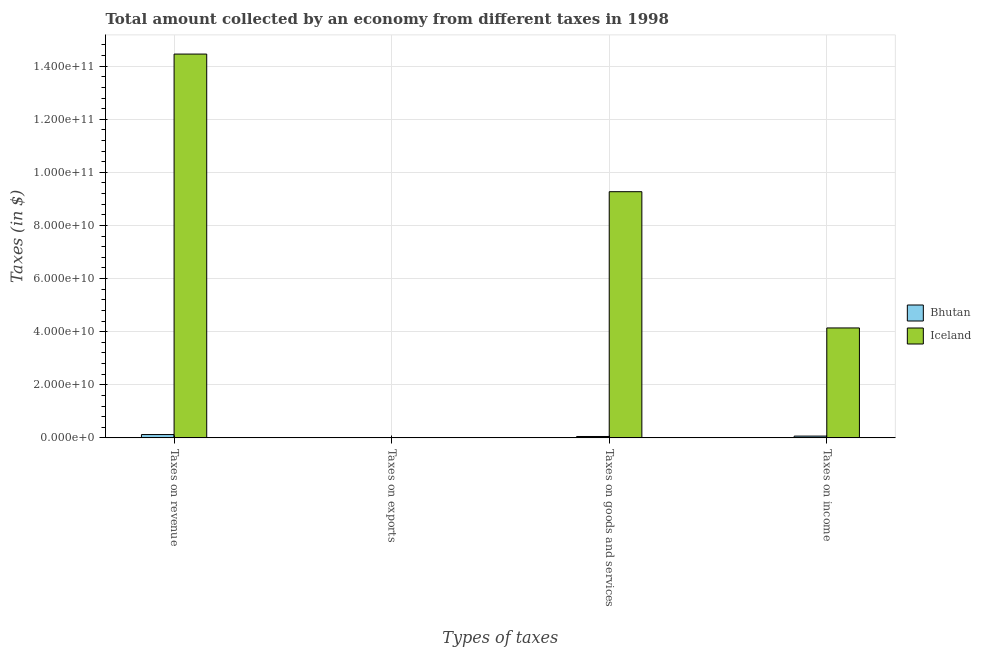How many groups of bars are there?
Your answer should be very brief. 4. Are the number of bars per tick equal to the number of legend labels?
Give a very brief answer. Yes. How many bars are there on the 1st tick from the right?
Your answer should be compact. 2. What is the label of the 3rd group of bars from the left?
Your answer should be very brief. Taxes on goods and services. What is the amount collected as tax on goods in Iceland?
Ensure brevity in your answer.  9.27e+1. Across all countries, what is the maximum amount collected as tax on income?
Provide a short and direct response. 4.14e+1. Across all countries, what is the minimum amount collected as tax on income?
Provide a succinct answer. 6.68e+08. In which country was the amount collected as tax on revenue minimum?
Provide a short and direct response. Bhutan. What is the total amount collected as tax on goods in the graph?
Give a very brief answer. 9.32e+1. What is the difference between the amount collected as tax on goods in Bhutan and that in Iceland?
Your response must be concise. -9.22e+1. What is the difference between the amount collected as tax on revenue in Iceland and the amount collected as tax on income in Bhutan?
Your response must be concise. 1.44e+11. What is the average amount collected as tax on revenue per country?
Your answer should be very brief. 7.29e+1. What is the difference between the amount collected as tax on exports and amount collected as tax on goods in Bhutan?
Give a very brief answer. -5.01e+08. What is the ratio of the amount collected as tax on revenue in Iceland to that in Bhutan?
Make the answer very short. 115.97. Is the amount collected as tax on revenue in Bhutan less than that in Iceland?
Offer a terse response. Yes. Is the difference between the amount collected as tax on exports in Bhutan and Iceland greater than the difference between the amount collected as tax on income in Bhutan and Iceland?
Offer a very short reply. Yes. What is the difference between the highest and the second highest amount collected as tax on exports?
Provide a short and direct response. 4.13e+07. What is the difference between the highest and the lowest amount collected as tax on goods?
Your answer should be compact. 9.22e+1. Is the sum of the amount collected as tax on exports in Iceland and Bhutan greater than the maximum amount collected as tax on goods across all countries?
Ensure brevity in your answer.  No. What does the 2nd bar from the left in Taxes on income represents?
Offer a terse response. Iceland. What does the 1st bar from the right in Taxes on goods and services represents?
Provide a succinct answer. Iceland. How many bars are there?
Your answer should be very brief. 8. What is the difference between two consecutive major ticks on the Y-axis?
Ensure brevity in your answer.  2.00e+1. Does the graph contain any zero values?
Provide a short and direct response. No. Where does the legend appear in the graph?
Offer a terse response. Center right. How are the legend labels stacked?
Your answer should be compact. Vertical. What is the title of the graph?
Keep it short and to the point. Total amount collected by an economy from different taxes in 1998. What is the label or title of the X-axis?
Make the answer very short. Types of taxes. What is the label or title of the Y-axis?
Keep it short and to the point. Taxes (in $). What is the Taxes (in $) in Bhutan in Taxes on revenue?
Offer a terse response. 1.25e+09. What is the Taxes (in $) of Iceland in Taxes on revenue?
Your response must be concise. 1.45e+11. What is the Taxes (in $) in Bhutan in Taxes on exports?
Your answer should be compact. 1.85e+07. What is the Taxes (in $) in Iceland in Taxes on exports?
Offer a very short reply. 5.98e+07. What is the Taxes (in $) in Bhutan in Taxes on goods and services?
Your response must be concise. 5.19e+08. What is the Taxes (in $) in Iceland in Taxes on goods and services?
Give a very brief answer. 9.27e+1. What is the Taxes (in $) of Bhutan in Taxes on income?
Provide a succinct answer. 6.68e+08. What is the Taxes (in $) in Iceland in Taxes on income?
Your answer should be compact. 4.14e+1. Across all Types of taxes, what is the maximum Taxes (in $) in Bhutan?
Provide a succinct answer. 1.25e+09. Across all Types of taxes, what is the maximum Taxes (in $) in Iceland?
Give a very brief answer. 1.45e+11. Across all Types of taxes, what is the minimum Taxes (in $) in Bhutan?
Keep it short and to the point. 1.85e+07. Across all Types of taxes, what is the minimum Taxes (in $) of Iceland?
Provide a short and direct response. 5.98e+07. What is the total Taxes (in $) in Bhutan in the graph?
Give a very brief answer. 2.45e+09. What is the total Taxes (in $) in Iceland in the graph?
Make the answer very short. 2.79e+11. What is the difference between the Taxes (in $) of Bhutan in Taxes on revenue and that in Taxes on exports?
Ensure brevity in your answer.  1.23e+09. What is the difference between the Taxes (in $) of Iceland in Taxes on revenue and that in Taxes on exports?
Make the answer very short. 1.44e+11. What is the difference between the Taxes (in $) in Bhutan in Taxes on revenue and that in Taxes on goods and services?
Ensure brevity in your answer.  7.27e+08. What is the difference between the Taxes (in $) in Iceland in Taxes on revenue and that in Taxes on goods and services?
Offer a very short reply. 5.18e+1. What is the difference between the Taxes (in $) of Bhutan in Taxes on revenue and that in Taxes on income?
Your answer should be very brief. 5.79e+08. What is the difference between the Taxes (in $) in Iceland in Taxes on revenue and that in Taxes on income?
Your answer should be very brief. 1.03e+11. What is the difference between the Taxes (in $) in Bhutan in Taxes on exports and that in Taxes on goods and services?
Offer a terse response. -5.01e+08. What is the difference between the Taxes (in $) in Iceland in Taxes on exports and that in Taxes on goods and services?
Give a very brief answer. -9.27e+1. What is the difference between the Taxes (in $) of Bhutan in Taxes on exports and that in Taxes on income?
Offer a terse response. -6.49e+08. What is the difference between the Taxes (in $) in Iceland in Taxes on exports and that in Taxes on income?
Make the answer very short. -4.13e+1. What is the difference between the Taxes (in $) in Bhutan in Taxes on goods and services and that in Taxes on income?
Your response must be concise. -1.49e+08. What is the difference between the Taxes (in $) in Iceland in Taxes on goods and services and that in Taxes on income?
Make the answer very short. 5.13e+1. What is the difference between the Taxes (in $) of Bhutan in Taxes on revenue and the Taxes (in $) of Iceland in Taxes on exports?
Give a very brief answer. 1.19e+09. What is the difference between the Taxes (in $) of Bhutan in Taxes on revenue and the Taxes (in $) of Iceland in Taxes on goods and services?
Provide a succinct answer. -9.15e+1. What is the difference between the Taxes (in $) of Bhutan in Taxes on revenue and the Taxes (in $) of Iceland in Taxes on income?
Offer a terse response. -4.02e+1. What is the difference between the Taxes (in $) of Bhutan in Taxes on exports and the Taxes (in $) of Iceland in Taxes on goods and services?
Your answer should be compact. -9.27e+1. What is the difference between the Taxes (in $) in Bhutan in Taxes on exports and the Taxes (in $) in Iceland in Taxes on income?
Offer a very short reply. -4.14e+1. What is the difference between the Taxes (in $) in Bhutan in Taxes on goods and services and the Taxes (in $) in Iceland in Taxes on income?
Ensure brevity in your answer.  -4.09e+1. What is the average Taxes (in $) in Bhutan per Types of taxes?
Give a very brief answer. 6.13e+08. What is the average Taxes (in $) in Iceland per Types of taxes?
Offer a very short reply. 6.97e+1. What is the difference between the Taxes (in $) in Bhutan and Taxes (in $) in Iceland in Taxes on revenue?
Ensure brevity in your answer.  -1.43e+11. What is the difference between the Taxes (in $) in Bhutan and Taxes (in $) in Iceland in Taxes on exports?
Provide a short and direct response. -4.13e+07. What is the difference between the Taxes (in $) of Bhutan and Taxes (in $) of Iceland in Taxes on goods and services?
Ensure brevity in your answer.  -9.22e+1. What is the difference between the Taxes (in $) in Bhutan and Taxes (in $) in Iceland in Taxes on income?
Your response must be concise. -4.07e+1. What is the ratio of the Taxes (in $) of Bhutan in Taxes on revenue to that in Taxes on exports?
Your response must be concise. 67.5. What is the ratio of the Taxes (in $) of Iceland in Taxes on revenue to that in Taxes on exports?
Offer a terse response. 2417.2. What is the ratio of the Taxes (in $) in Bhutan in Taxes on revenue to that in Taxes on goods and services?
Offer a very short reply. 2.4. What is the ratio of the Taxes (in $) of Iceland in Taxes on revenue to that in Taxes on goods and services?
Offer a terse response. 1.56. What is the ratio of the Taxes (in $) in Bhutan in Taxes on revenue to that in Taxes on income?
Make the answer very short. 1.87. What is the ratio of the Taxes (in $) of Iceland in Taxes on revenue to that in Taxes on income?
Your answer should be compact. 3.49. What is the ratio of the Taxes (in $) in Bhutan in Taxes on exports to that in Taxes on goods and services?
Keep it short and to the point. 0.04. What is the ratio of the Taxes (in $) in Iceland in Taxes on exports to that in Taxes on goods and services?
Give a very brief answer. 0. What is the ratio of the Taxes (in $) in Bhutan in Taxes on exports to that in Taxes on income?
Your answer should be compact. 0.03. What is the ratio of the Taxes (in $) of Iceland in Taxes on exports to that in Taxes on income?
Your response must be concise. 0. What is the ratio of the Taxes (in $) of Bhutan in Taxes on goods and services to that in Taxes on income?
Make the answer very short. 0.78. What is the ratio of the Taxes (in $) in Iceland in Taxes on goods and services to that in Taxes on income?
Give a very brief answer. 2.24. What is the difference between the highest and the second highest Taxes (in $) of Bhutan?
Offer a terse response. 5.79e+08. What is the difference between the highest and the second highest Taxes (in $) in Iceland?
Provide a succinct answer. 5.18e+1. What is the difference between the highest and the lowest Taxes (in $) of Bhutan?
Your answer should be compact. 1.23e+09. What is the difference between the highest and the lowest Taxes (in $) in Iceland?
Keep it short and to the point. 1.44e+11. 